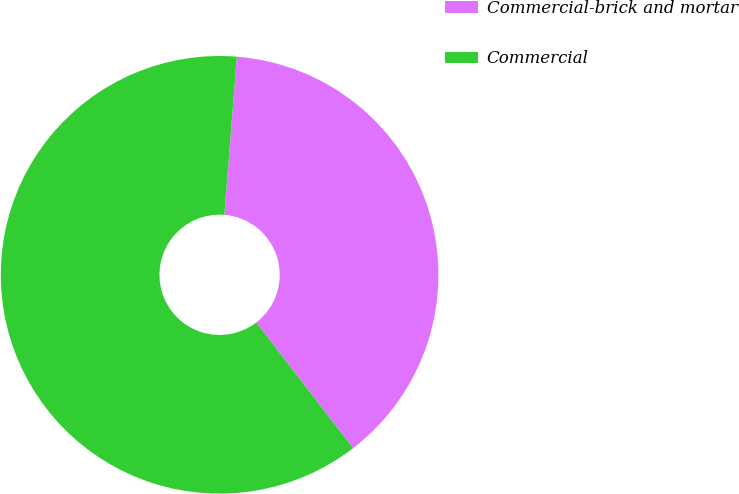Convert chart. <chart><loc_0><loc_0><loc_500><loc_500><pie_chart><fcel>Commercial-brick and mortar<fcel>Commercial<nl><fcel>38.3%<fcel>61.7%<nl></chart> 